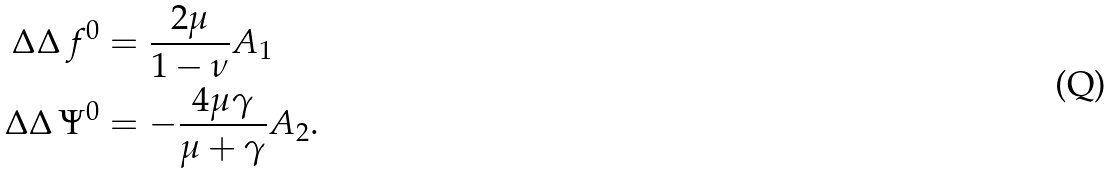<formula> <loc_0><loc_0><loc_500><loc_500>\Delta \Delta \, f ^ { 0 } & = \frac { 2 \mu } { 1 - \nu } A _ { 1 } \\ \Delta \Delta \, \Psi ^ { 0 } & = - \frac { 4 \mu \gamma } { \mu + \gamma } A _ { 2 } .</formula> 